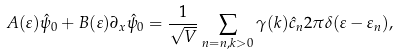Convert formula to latex. <formula><loc_0><loc_0><loc_500><loc_500>A ( \varepsilon ) \hat { \psi } _ { 0 } + B ( \varepsilon ) \partial _ { x } \hat { \psi } _ { 0 } = \frac { 1 } { \sqrt { V } } \sum _ { n = n , k > 0 } \gamma ( k ) \hat { c } _ { n } 2 \pi \delta ( \varepsilon - \varepsilon _ { n } ) ,</formula> 